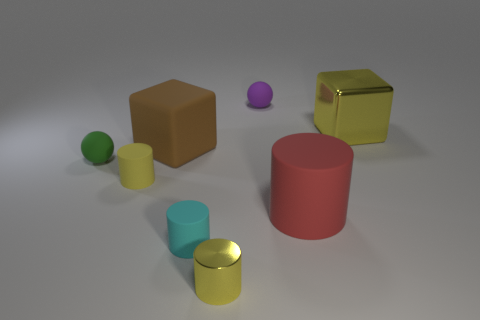Subtract 2 cylinders. How many cylinders are left? 2 Subtract all small cylinders. How many cylinders are left? 1 Subtract all cyan cylinders. How many cylinders are left? 3 Add 1 red matte objects. How many objects exist? 9 Subtract all brown cylinders. Subtract all cyan balls. How many cylinders are left? 4 Subtract all balls. How many objects are left? 6 Subtract all brown matte objects. Subtract all purple things. How many objects are left? 6 Add 4 yellow blocks. How many yellow blocks are left? 5 Add 1 cylinders. How many cylinders exist? 5 Subtract 0 purple cylinders. How many objects are left? 8 